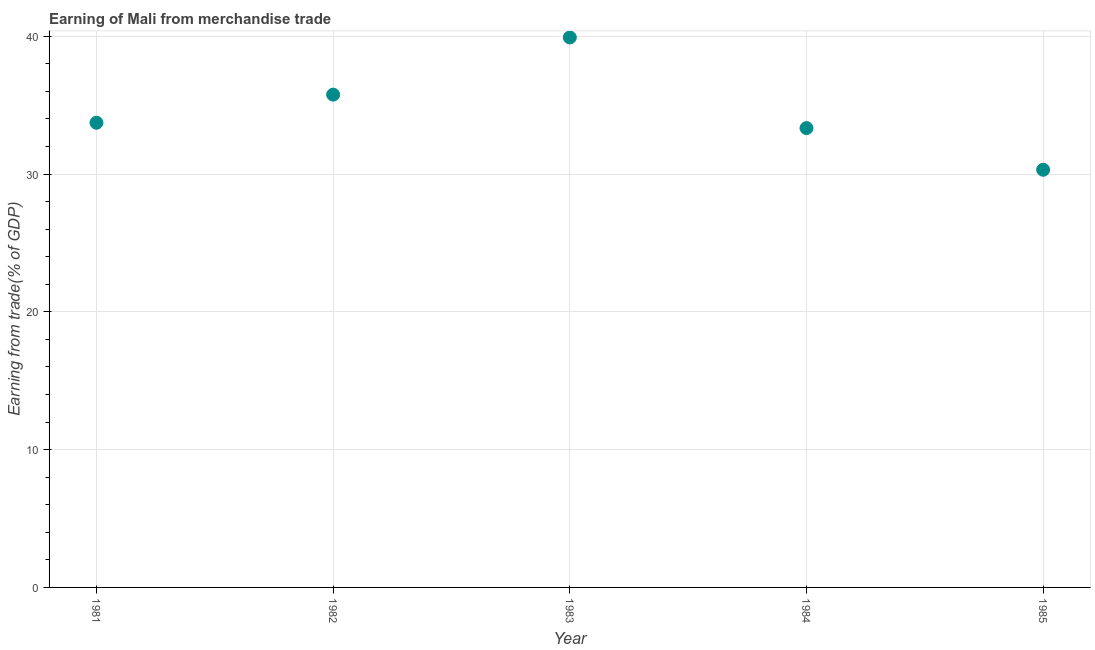What is the earning from merchandise trade in 1983?
Your answer should be compact. 39.91. Across all years, what is the maximum earning from merchandise trade?
Your answer should be very brief. 39.91. Across all years, what is the minimum earning from merchandise trade?
Your answer should be compact. 30.31. In which year was the earning from merchandise trade maximum?
Provide a short and direct response. 1983. What is the sum of the earning from merchandise trade?
Provide a succinct answer. 173.05. What is the difference between the earning from merchandise trade in 1982 and 1984?
Offer a very short reply. 2.43. What is the average earning from merchandise trade per year?
Provide a short and direct response. 34.61. What is the median earning from merchandise trade?
Offer a very short reply. 33.72. In how many years, is the earning from merchandise trade greater than 26 %?
Offer a terse response. 5. Do a majority of the years between 1983 and 1984 (inclusive) have earning from merchandise trade greater than 36 %?
Offer a terse response. No. What is the ratio of the earning from merchandise trade in 1982 to that in 1984?
Ensure brevity in your answer.  1.07. Is the difference between the earning from merchandise trade in 1983 and 1985 greater than the difference between any two years?
Your answer should be very brief. Yes. What is the difference between the highest and the second highest earning from merchandise trade?
Offer a very short reply. 4.15. What is the difference between the highest and the lowest earning from merchandise trade?
Make the answer very short. 9.6. In how many years, is the earning from merchandise trade greater than the average earning from merchandise trade taken over all years?
Ensure brevity in your answer.  2. Does the earning from merchandise trade monotonically increase over the years?
Give a very brief answer. No. How many years are there in the graph?
Ensure brevity in your answer.  5. Are the values on the major ticks of Y-axis written in scientific E-notation?
Provide a succinct answer. No. What is the title of the graph?
Give a very brief answer. Earning of Mali from merchandise trade. What is the label or title of the X-axis?
Keep it short and to the point. Year. What is the label or title of the Y-axis?
Keep it short and to the point. Earning from trade(% of GDP). What is the Earning from trade(% of GDP) in 1981?
Provide a succinct answer. 33.72. What is the Earning from trade(% of GDP) in 1982?
Ensure brevity in your answer.  35.76. What is the Earning from trade(% of GDP) in 1983?
Your response must be concise. 39.91. What is the Earning from trade(% of GDP) in 1984?
Offer a terse response. 33.34. What is the Earning from trade(% of GDP) in 1985?
Keep it short and to the point. 30.31. What is the difference between the Earning from trade(% of GDP) in 1981 and 1982?
Offer a very short reply. -2.04. What is the difference between the Earning from trade(% of GDP) in 1981 and 1983?
Give a very brief answer. -6.19. What is the difference between the Earning from trade(% of GDP) in 1981 and 1984?
Offer a terse response. 0.39. What is the difference between the Earning from trade(% of GDP) in 1981 and 1985?
Offer a terse response. 3.41. What is the difference between the Earning from trade(% of GDP) in 1982 and 1983?
Give a very brief answer. -4.15. What is the difference between the Earning from trade(% of GDP) in 1982 and 1984?
Your answer should be very brief. 2.43. What is the difference between the Earning from trade(% of GDP) in 1982 and 1985?
Ensure brevity in your answer.  5.45. What is the difference between the Earning from trade(% of GDP) in 1983 and 1984?
Your answer should be compact. 6.58. What is the difference between the Earning from trade(% of GDP) in 1983 and 1985?
Offer a very short reply. 9.6. What is the difference between the Earning from trade(% of GDP) in 1984 and 1985?
Provide a succinct answer. 3.02. What is the ratio of the Earning from trade(% of GDP) in 1981 to that in 1982?
Offer a very short reply. 0.94. What is the ratio of the Earning from trade(% of GDP) in 1981 to that in 1983?
Make the answer very short. 0.84. What is the ratio of the Earning from trade(% of GDP) in 1981 to that in 1984?
Make the answer very short. 1.01. What is the ratio of the Earning from trade(% of GDP) in 1981 to that in 1985?
Make the answer very short. 1.11. What is the ratio of the Earning from trade(% of GDP) in 1982 to that in 1983?
Provide a short and direct response. 0.9. What is the ratio of the Earning from trade(% of GDP) in 1982 to that in 1984?
Keep it short and to the point. 1.07. What is the ratio of the Earning from trade(% of GDP) in 1982 to that in 1985?
Your answer should be very brief. 1.18. What is the ratio of the Earning from trade(% of GDP) in 1983 to that in 1984?
Provide a short and direct response. 1.2. What is the ratio of the Earning from trade(% of GDP) in 1983 to that in 1985?
Give a very brief answer. 1.32. What is the ratio of the Earning from trade(% of GDP) in 1984 to that in 1985?
Provide a short and direct response. 1.1. 